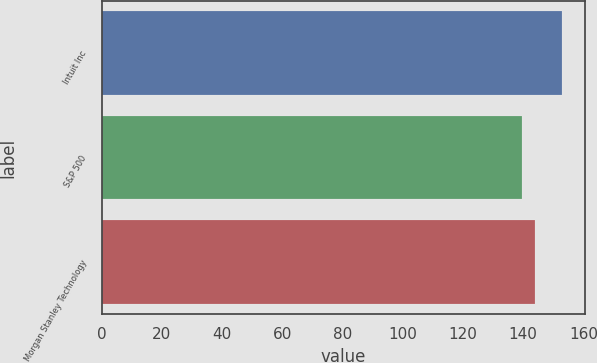<chart> <loc_0><loc_0><loc_500><loc_500><bar_chart><fcel>Intuit Inc<fcel>S&P 500<fcel>Morgan Stanley Technology<nl><fcel>152.99<fcel>139.58<fcel>144.03<nl></chart> 